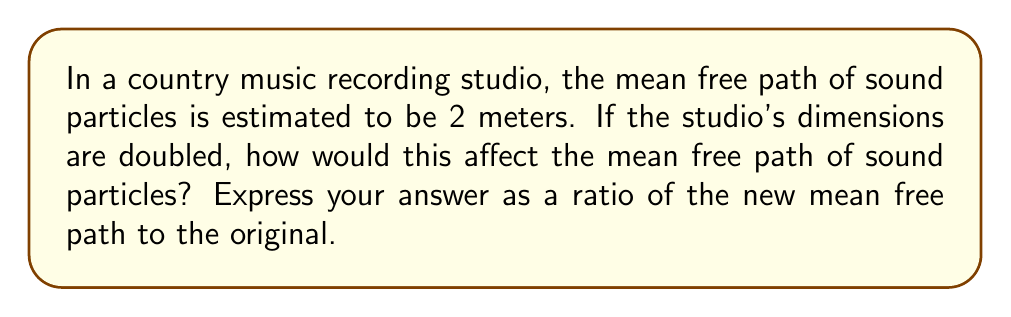Solve this math problem. To solve this problem, we need to understand the relationship between the mean free path and the dimensions of the container (in this case, the studio).

1) The mean free path $\lambda$ is inversely proportional to the number density $n$ of the particles:

   $$\lambda \propto \frac{1}{n}$$

2) The number density $n$ is inversely proportional to the volume $V$ of the container:

   $$n \propto \frac{1}{V}$$

3) Combining these, we get:

   $$\lambda \propto V$$

4) If all dimensions of the studio are doubled, the new volume $V_{new}$ is related to the original volume $V_{old}$ as follows:

   $$V_{new} = 2 \times 2 \times 2 \times V_{old} = 8V_{old}$$

5) Since the mean free path is directly proportional to the volume, we can write:

   $$\frac{\lambda_{new}}{\lambda_{old}} = \frac{V_{new}}{V_{old}} = 8$$

Therefore, the new mean free path will be 8 times the original mean free path.
Answer: 8:1 